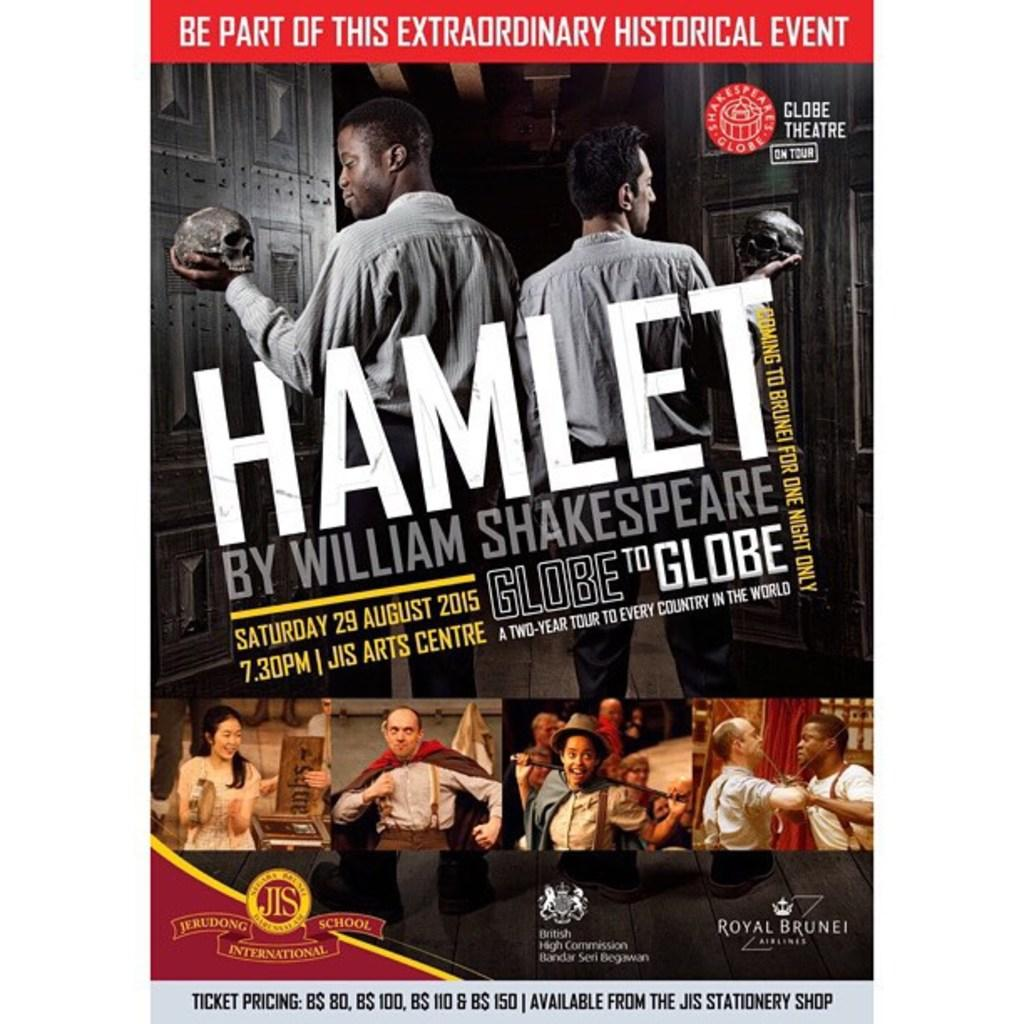<image>
Provide a brief description of the given image. Jerudong International school is putting on a performance of Hamlet. 